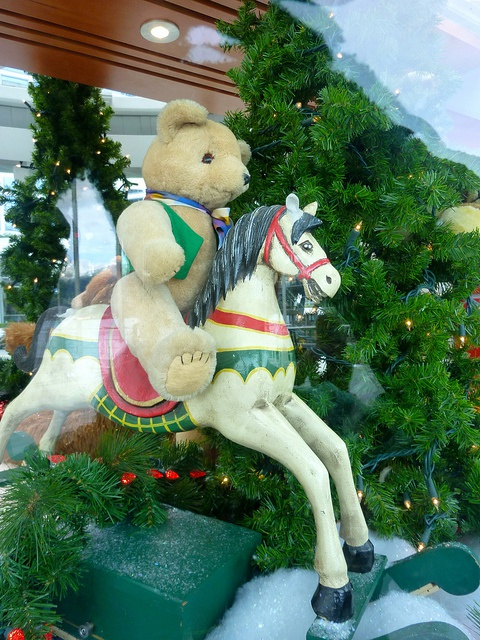Describe the objects in this image and their specific colors. I can see horse in brown, beige, darkgray, and gray tones and teddy bear in brown, beige, and tan tones in this image. 